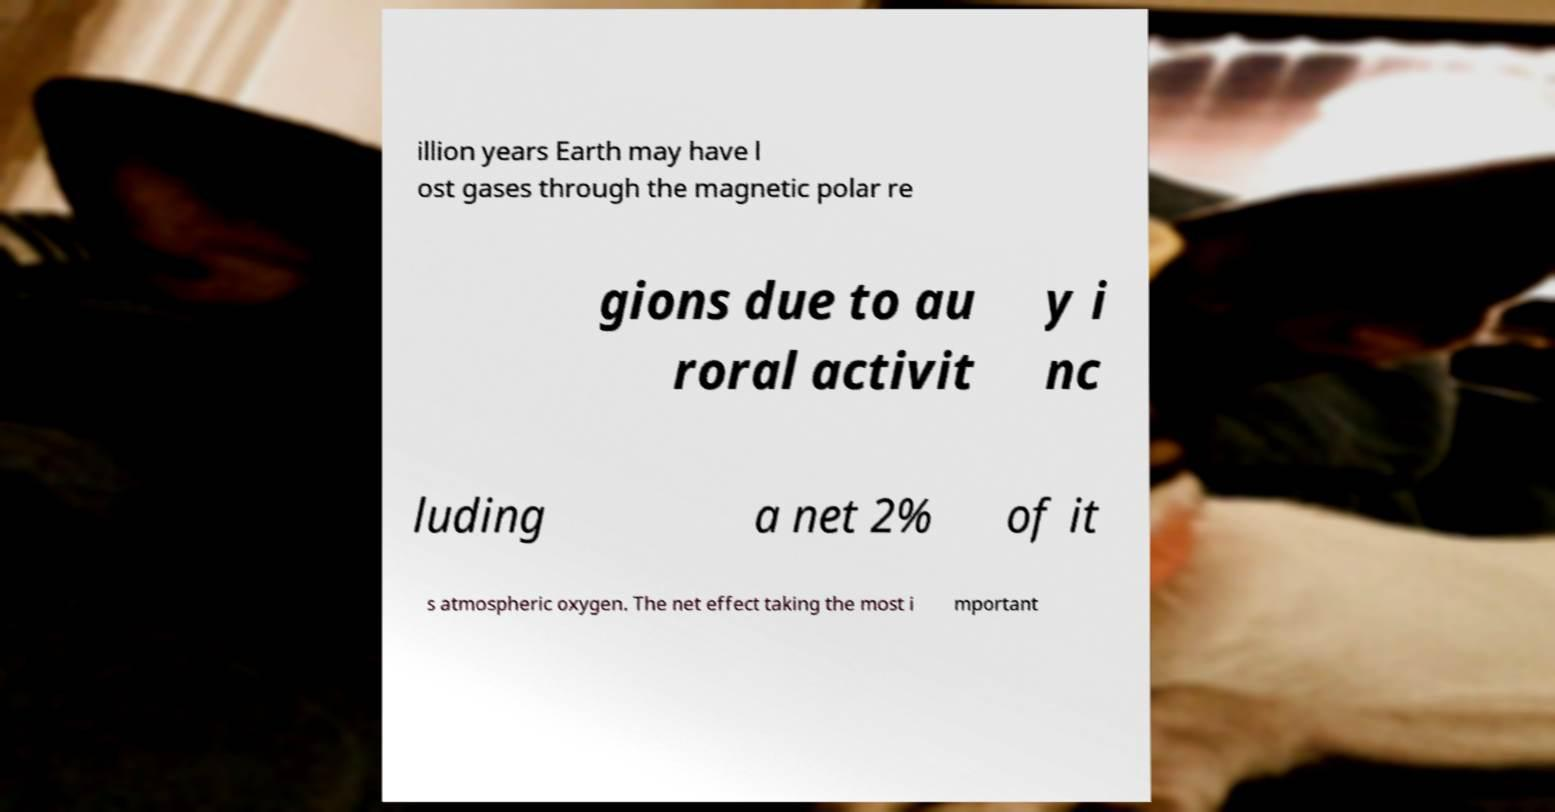Can you accurately transcribe the text from the provided image for me? illion years Earth may have l ost gases through the magnetic polar re gions due to au roral activit y i nc luding a net 2% of it s atmospheric oxygen. The net effect taking the most i mportant 